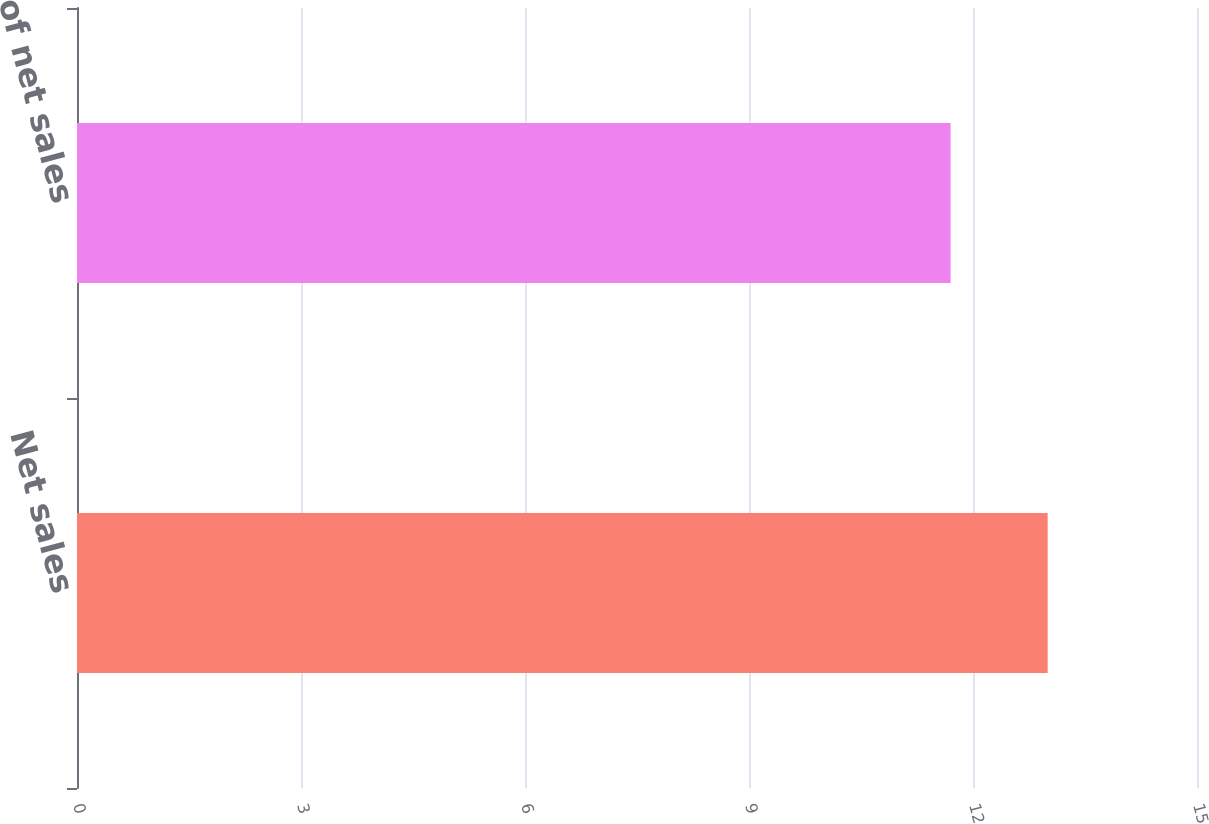Convert chart. <chart><loc_0><loc_0><loc_500><loc_500><bar_chart><fcel>Net sales<fcel>of net sales<nl><fcel>13<fcel>11.7<nl></chart> 